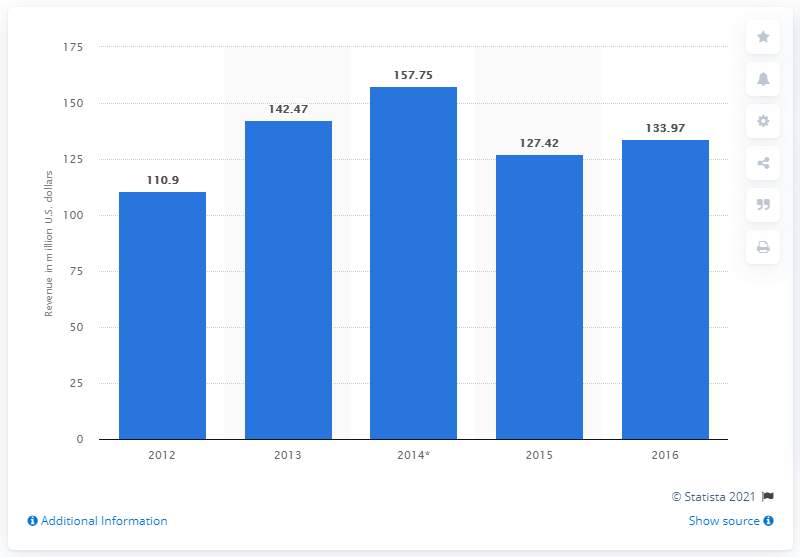Specify some key components in this picture. In 2016, the revenue of Goodlife Health Clubs Australia was 133.97. 